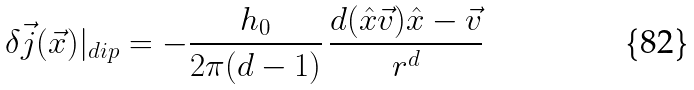Convert formula to latex. <formula><loc_0><loc_0><loc_500><loc_500>\delta \vec { j } ( \vec { x } ) | _ { d i p } = - \frac { h _ { 0 } } { 2 \pi ( d - 1 ) } \, \frac { d ( \hat { x } \vec { v } ) \hat { x } - \vec { v } } { r ^ { d } }</formula> 